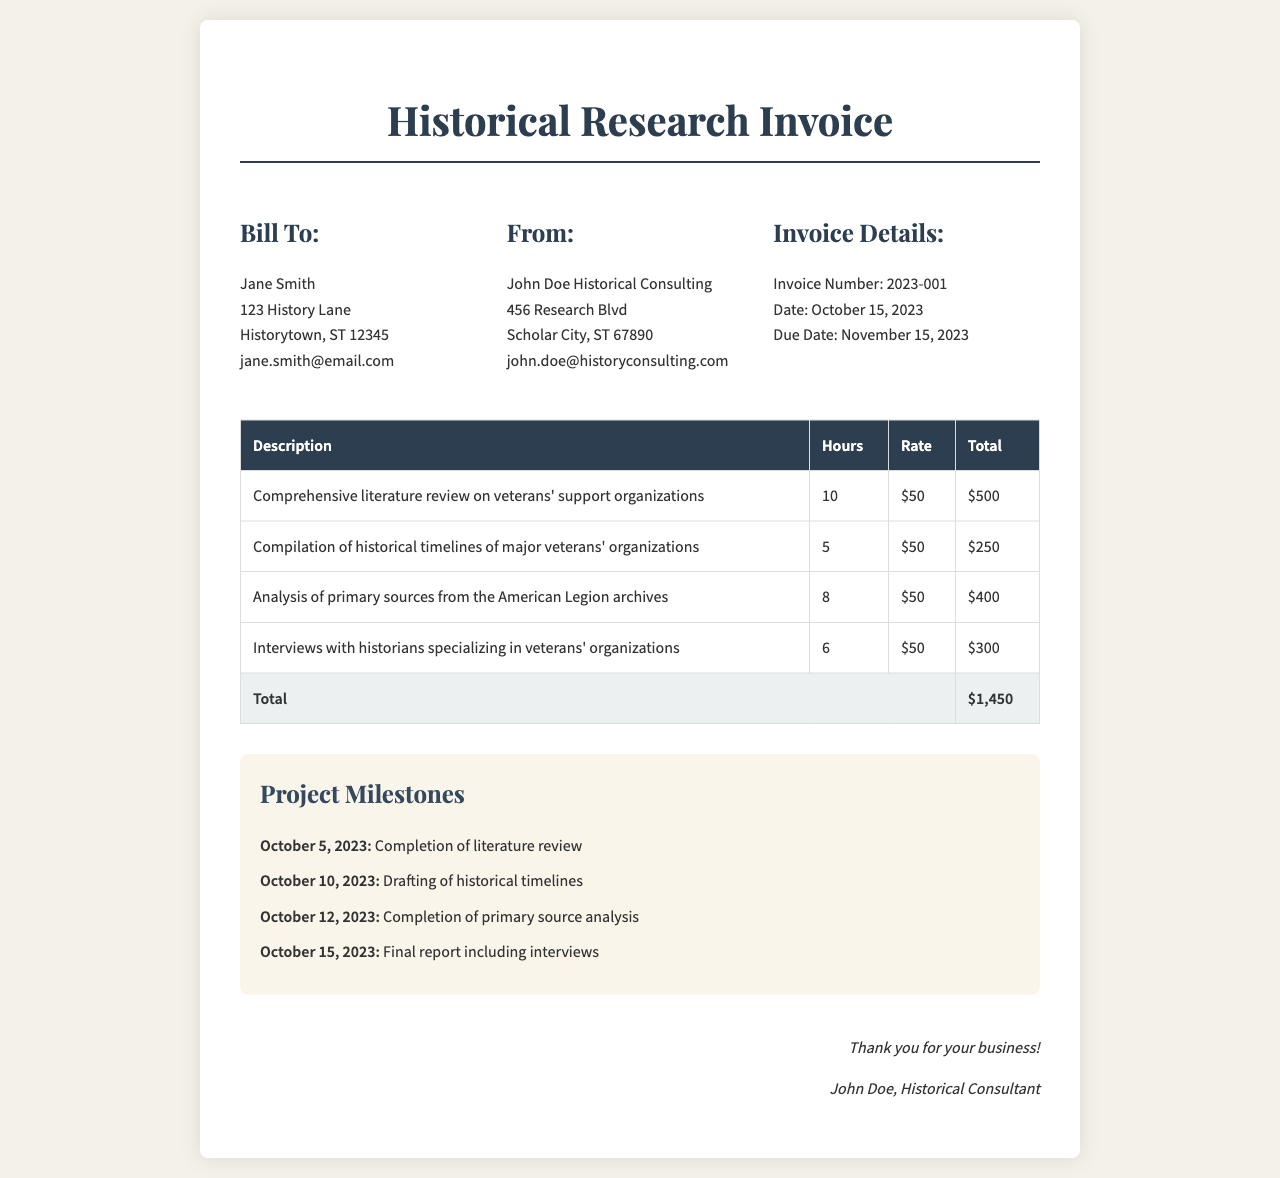What is the invoice number? The invoice number is a specific identifier for the document, listed under Invoice Details.
Answer: 2023-001 Who is the consultant? The consultant's name is provided under the "From" section of the invoice.
Answer: John Doe Historical Consulting What is the total amount due? The total amount due is calculated by summing the total of all services rendered in the invoice.
Answer: $1,450 What is the due date for payment? The due date is specified in the Invoice Details section.
Answer: November 15, 2023 On what date was the literature review completed? The completion date of the literature review is provided in the Project Milestones section.
Answer: October 5, 2023 How many hours were spent on interviews? The number of hours spent on interviews is listed in the service breakdown table.
Answer: 6 What was the rate for the services? The rate per hour for the services is uniform across the service items in the invoice.
Answer: $50 How many project milestones are listed? The number of project milestones is determined by counting the entries in the Project Milestones section.
Answer: 4 What was the total number of hours worked? The total number of hours worked can be calculated by adding up all hours listed for each service in the table.
Answer: 39 